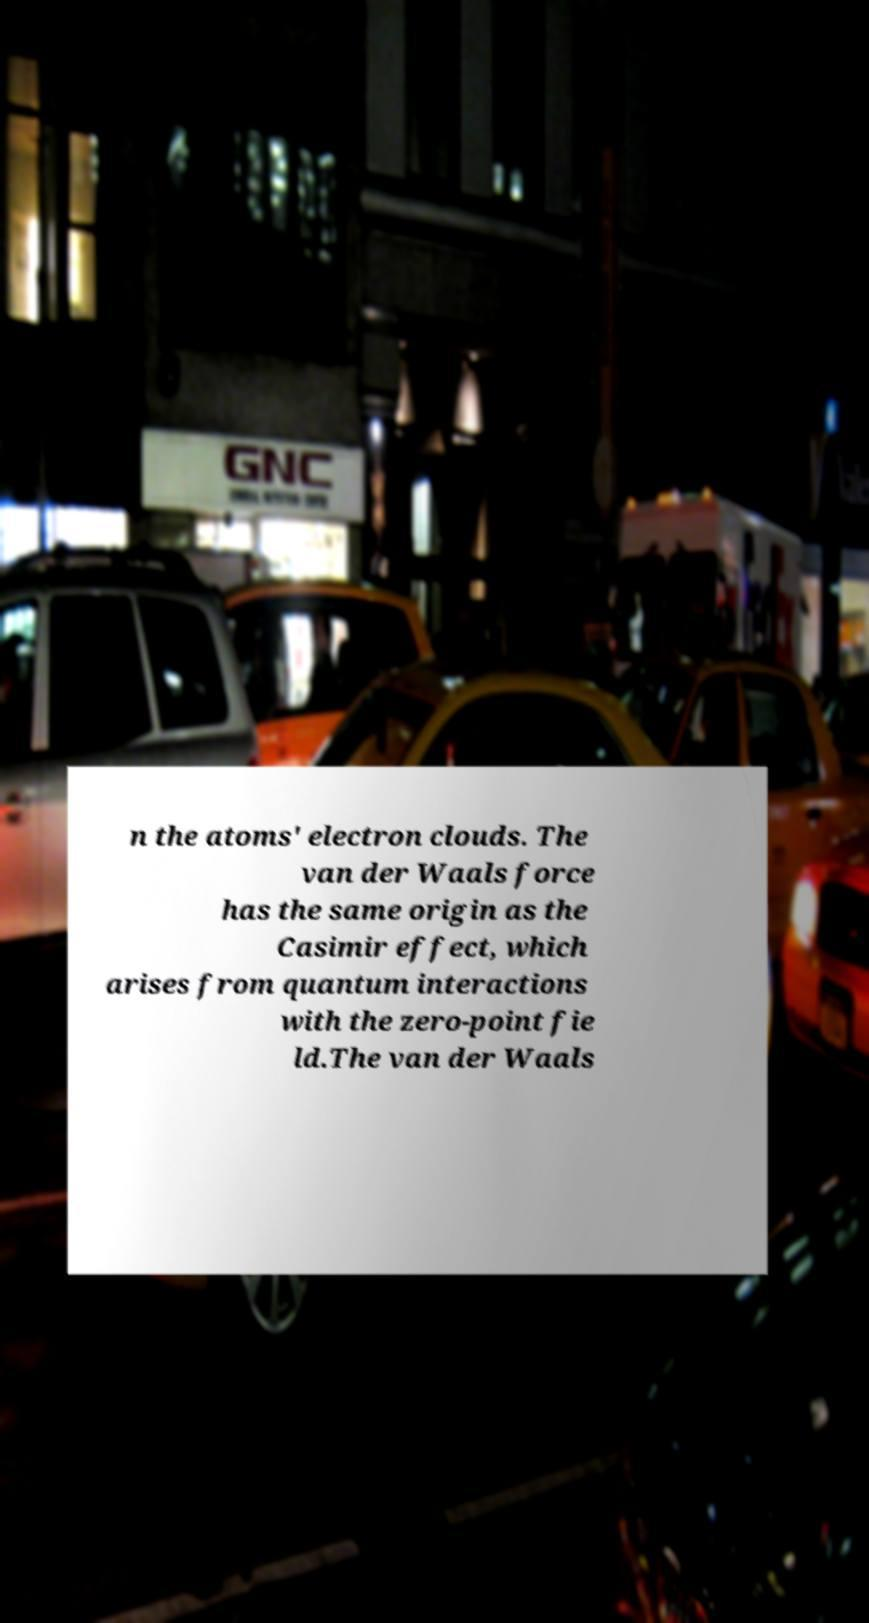There's text embedded in this image that I need extracted. Can you transcribe it verbatim? n the atoms' electron clouds. The van der Waals force has the same origin as the Casimir effect, which arises from quantum interactions with the zero-point fie ld.The van der Waals 